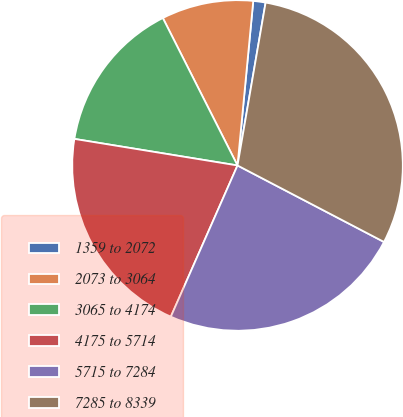Convert chart. <chart><loc_0><loc_0><loc_500><loc_500><pie_chart><fcel>1359 to 2072<fcel>2073 to 3064<fcel>3065 to 4174<fcel>4175 to 5714<fcel>5715 to 7284<fcel>7285 to 8339<nl><fcel>1.2%<fcel>8.98%<fcel>14.97%<fcel>20.96%<fcel>23.95%<fcel>29.94%<nl></chart> 